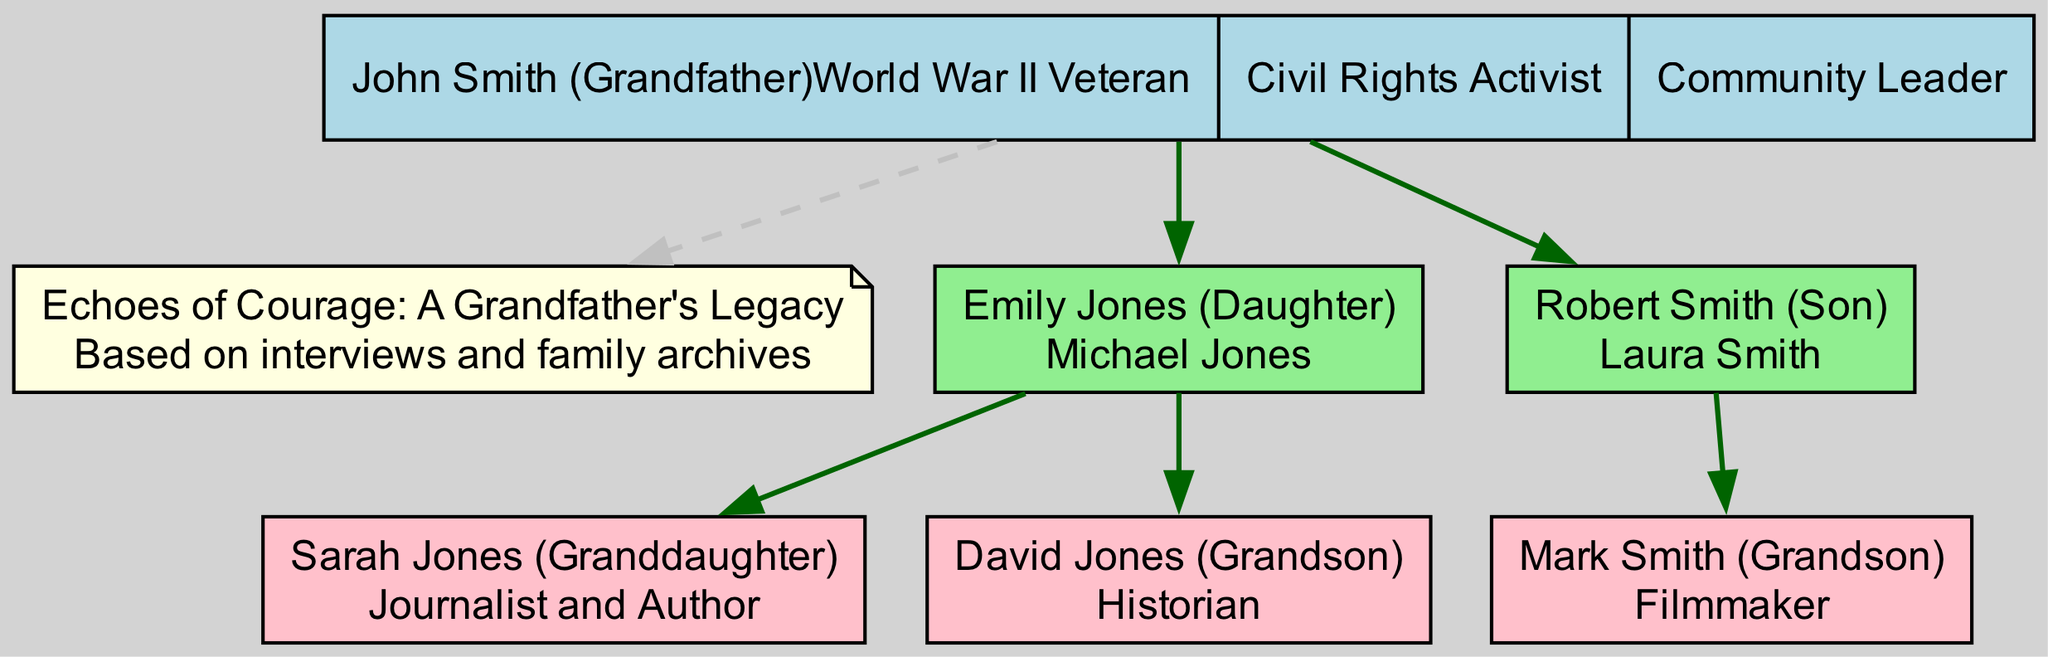What is the name of the grandfather in the family tree? The root node of the diagram identifies the grandfather as "John Smith."
Answer: John Smith How many children does John Smith have? The diagram shows two children listed under John Smith: Emily Jones and Robert Smith.
Answer: 2 What occupations do the grandchildren have? The diagram lists Sarah Jones as a Journalist and Author, David Jones as a Historian, and Mark Smith as a Filmmaker. This requires combining the grandchildren's nodes to summarize their occupations.
Answer: Journalist and Author, Historian, Filmmaker Who is Mark Smith's father? From the family tree, Mark Smith is shown as the child of Robert Smith, which is indicated by the edge connecting them.
Answer: Robert Smith Which key event is associated with John Smith? The diagram notes that John Smith is a World War II Veteran, as part of the key events associated with the grandfather.
Answer: World War II Veteran How many total grandchildren does John Smith have? The diagram states that John Smith has three grandchildren: Sarah Jones, David Jones, and Mark Smith. This counting requires examining all children of both of his children.
Answer: 3 Which spouse is linked to Emily Jones? The diagram presents Emily Jones as being married to Michael Jones, indicated in her node.
Answer: Michael Jones Which node represents the book related to the grandfather's legacy? The diagram includes a node specifically labeled as the title of the book, "Echoes of Courage: A Grandfather's Legacy," associated with John Smith.
Answer: Echoes of Courage: A Grandfather's Legacy Who occupies the position of the youngest grandchild? The youngest grandchild likely refers to the last grandchild listed in the order, which from the diagram seems to be Mark Smith as he is the last added to Robert Smith's children.
Answer: Mark Smith 